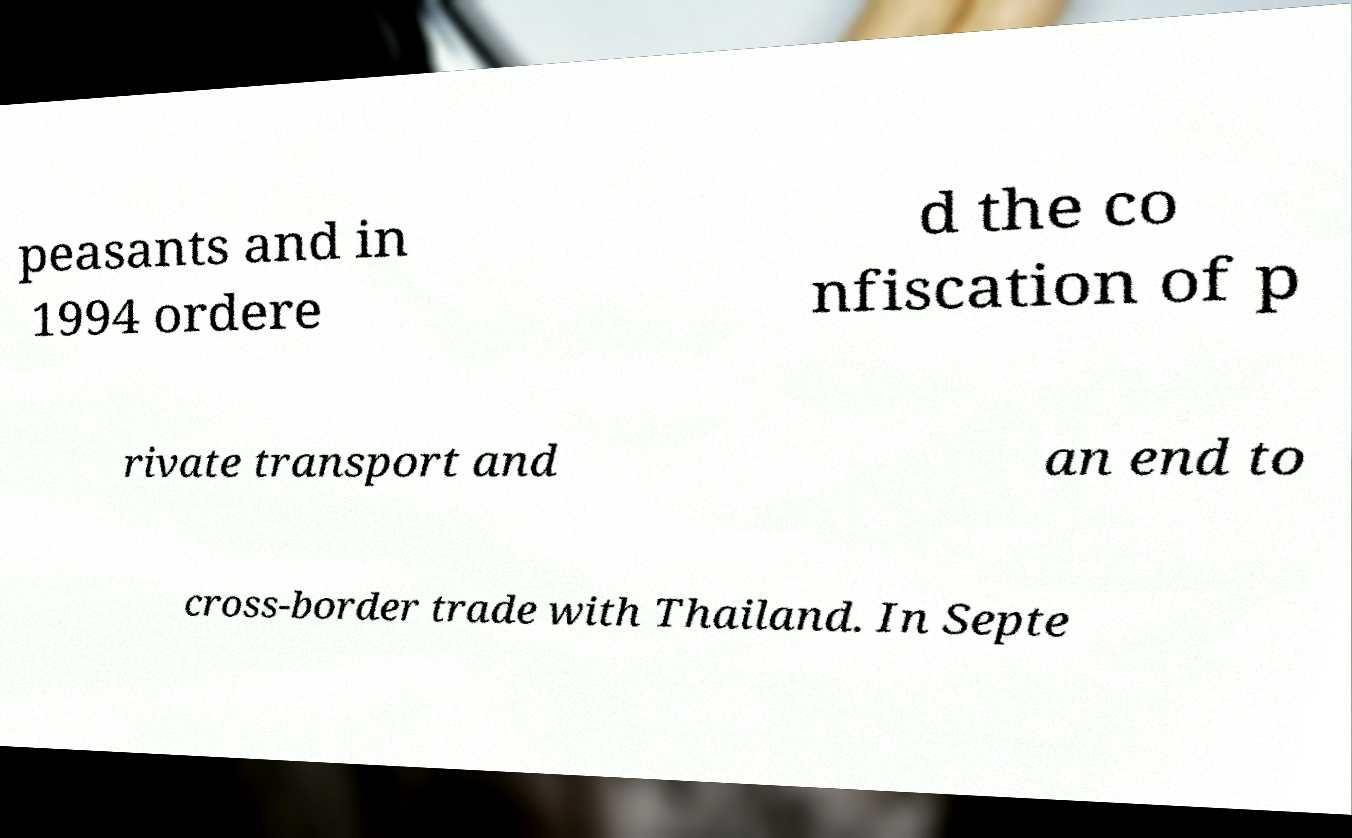What messages or text are displayed in this image? I need them in a readable, typed format. peasants and in 1994 ordere d the co nfiscation of p rivate transport and an end to cross-border trade with Thailand. In Septe 